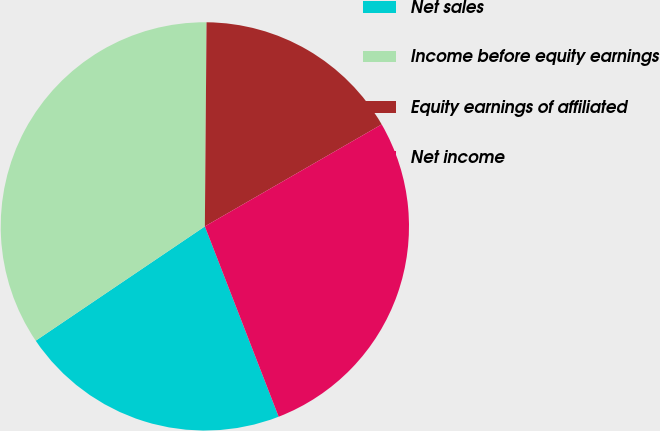<chart> <loc_0><loc_0><loc_500><loc_500><pie_chart><fcel>Net sales<fcel>Income before equity earnings<fcel>Equity earnings of affiliated<fcel>Net income<nl><fcel>21.43%<fcel>34.59%<fcel>16.54%<fcel>27.44%<nl></chart> 